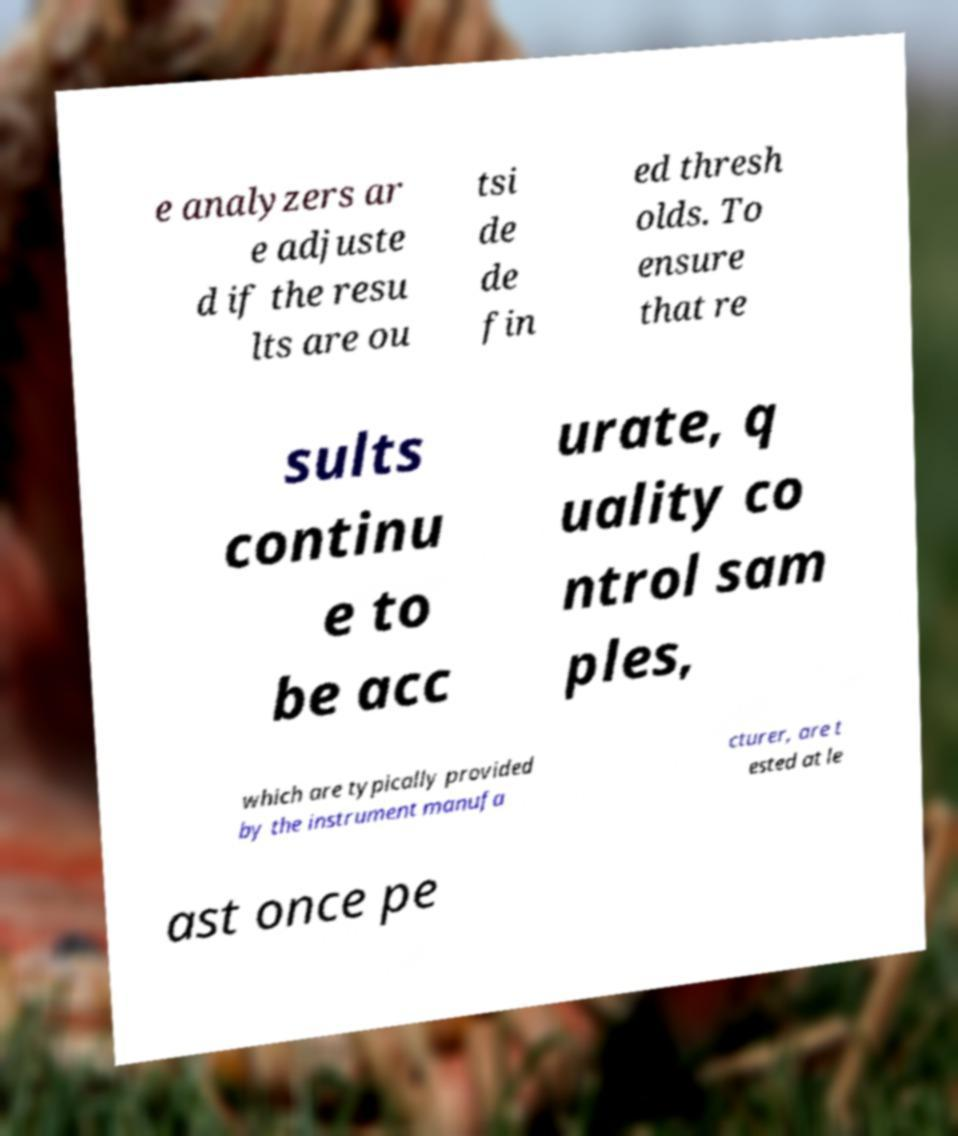There's text embedded in this image that I need extracted. Can you transcribe it verbatim? e analyzers ar e adjuste d if the resu lts are ou tsi de de fin ed thresh olds. To ensure that re sults continu e to be acc urate, q uality co ntrol sam ples, which are typically provided by the instrument manufa cturer, are t ested at le ast once pe 